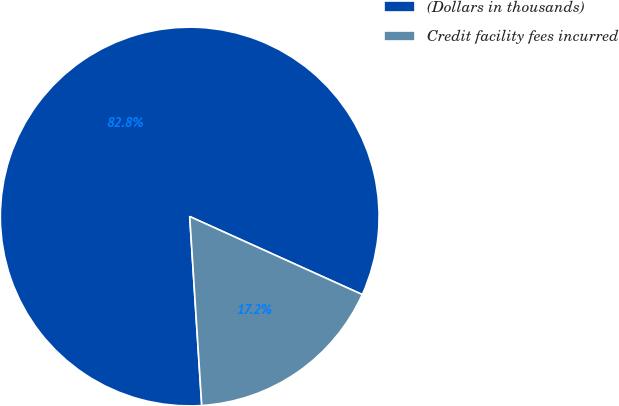Convert chart. <chart><loc_0><loc_0><loc_500><loc_500><pie_chart><fcel>(Dollars in thousands)<fcel>Credit facility fees incurred<nl><fcel>82.77%<fcel>17.23%<nl></chart> 